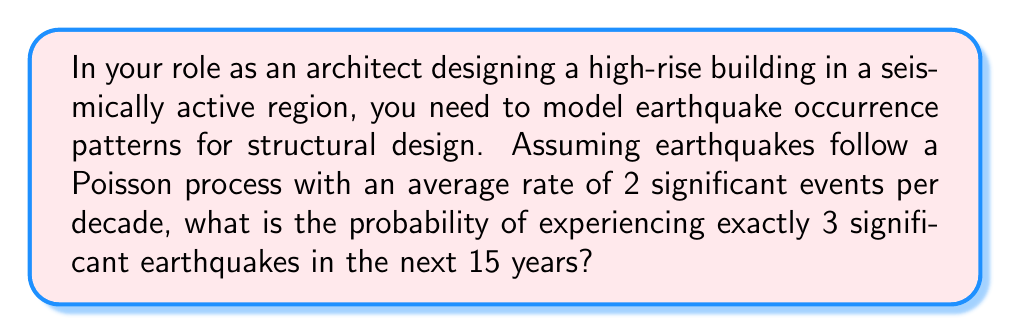Teach me how to tackle this problem. Let's approach this step-by-step:

1) First, we identify that we're dealing with a Poisson process. The Poisson distribution is used to model the number of events occurring in a fixed interval of time or space.

2) We're given that the average rate is 2 significant events per decade. We need to adjust this for our 15-year period:

   Rate for 15 years = $2 \times \frac{15}{10} = 3$ events

3) Let $\lambda = 3$ be our adjusted rate for the 15-year period.

4) The probability mass function for a Poisson distribution is:

   $$P(X = k) = \frac{e^{-\lambda}\lambda^k}{k!}$$

   Where $X$ is the number of events, $k$ is the specific number we're interested in, and $\lambda$ is the rate.

5) We want $P(X = 3)$, so we plug in our values:

   $$P(X = 3) = \frac{e^{-3}3^3}{3!}$$

6) Let's calculate this step-by-step:
   
   $3^3 = 27$
   $3! = 6$
   $e^{-3} \approx 0.0498$

   $$P(X = 3) = \frac{0.0498 \times 27}{6} \approx 0.2240$$

7) Therefore, the probability of experiencing exactly 3 significant earthquakes in the next 15 years is approximately 0.2240 or 22.40%.
Answer: 0.2240 